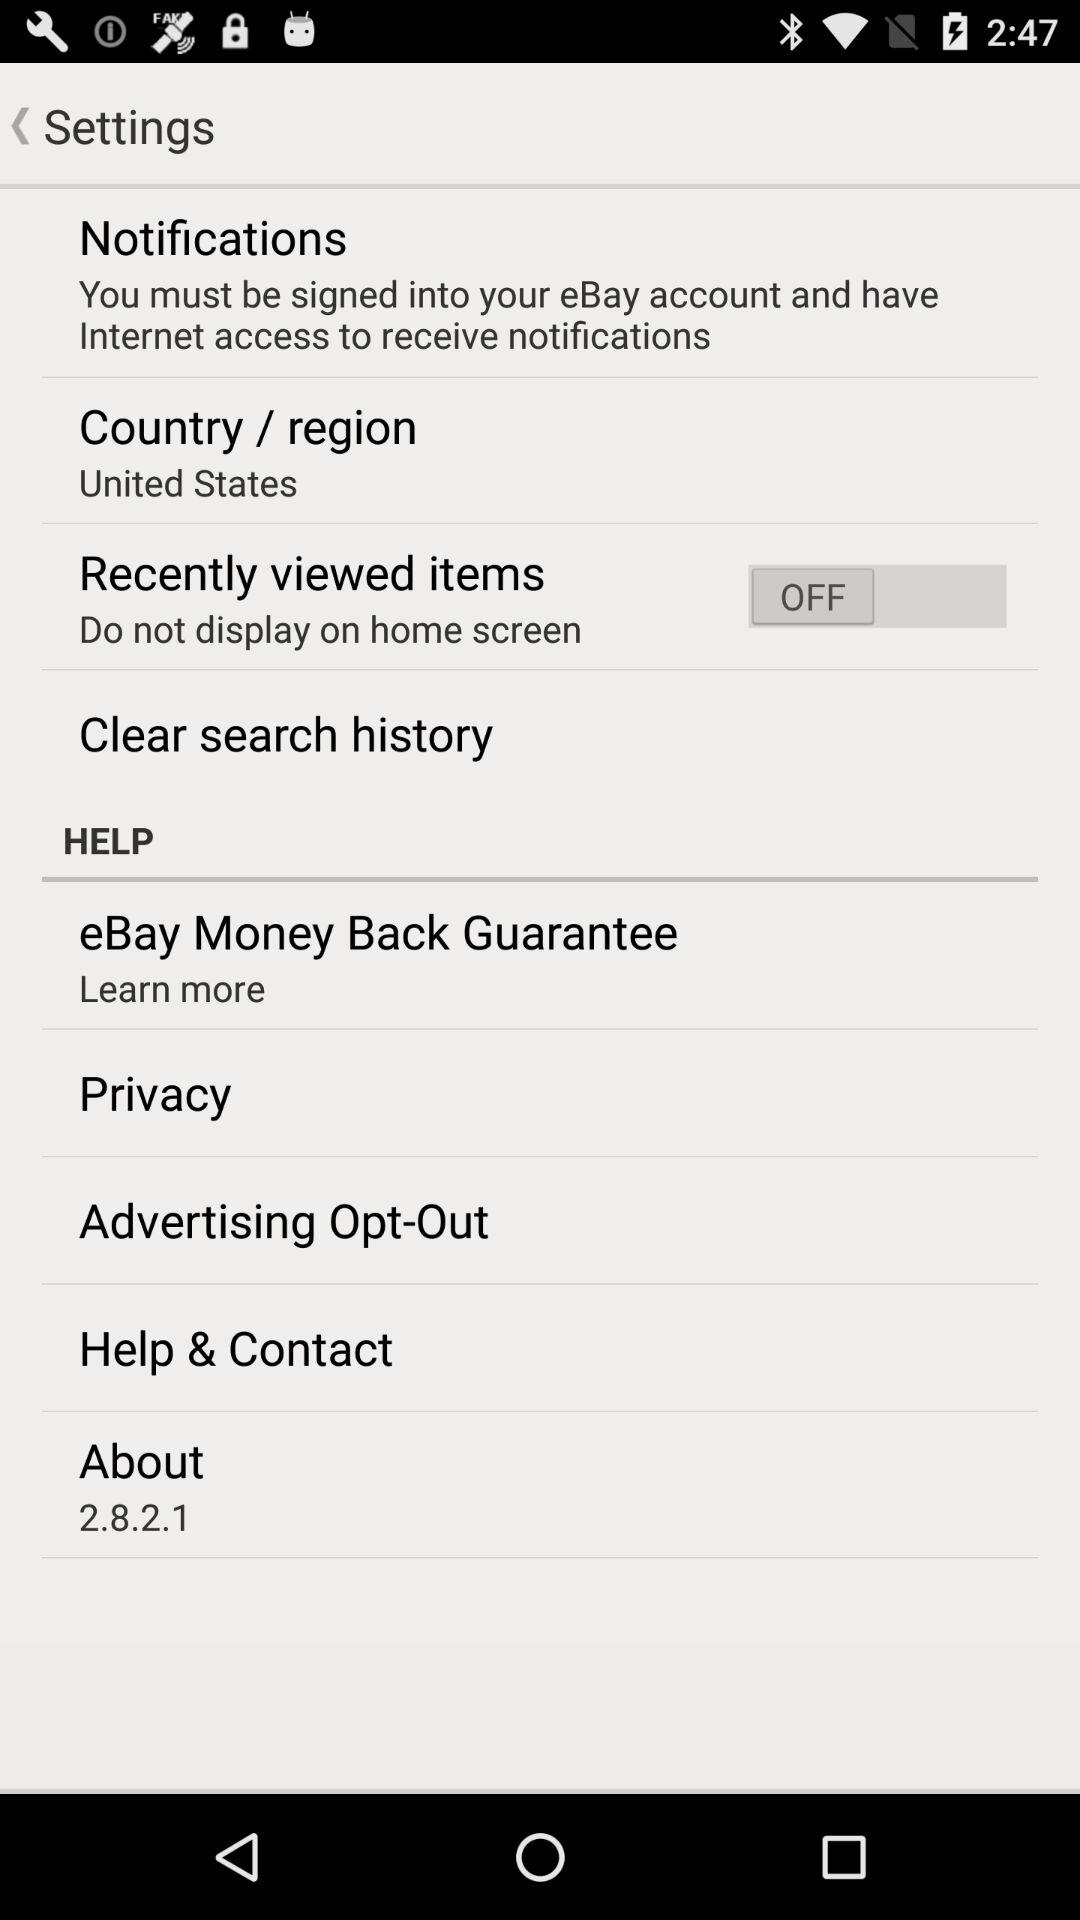What version is used? The version is 2.8.2.1. 